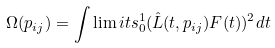<formula> <loc_0><loc_0><loc_500><loc_500>\Omega ( p _ { i j } ) = \int \lim i t s _ { 0 } ^ { 1 } { ( \hat { L } ( t , p _ { i j } ) F ( t ) ) ^ { 2 } d t }</formula> 